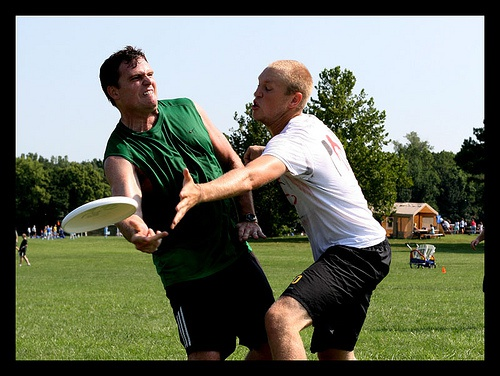Describe the objects in this image and their specific colors. I can see people in black, maroon, white, and green tones, people in black, white, gray, and maroon tones, frisbee in black, olive, white, and gray tones, people in black, gray, olive, and darkgray tones, and people in black, darkgreen, gray, and lightgray tones in this image. 